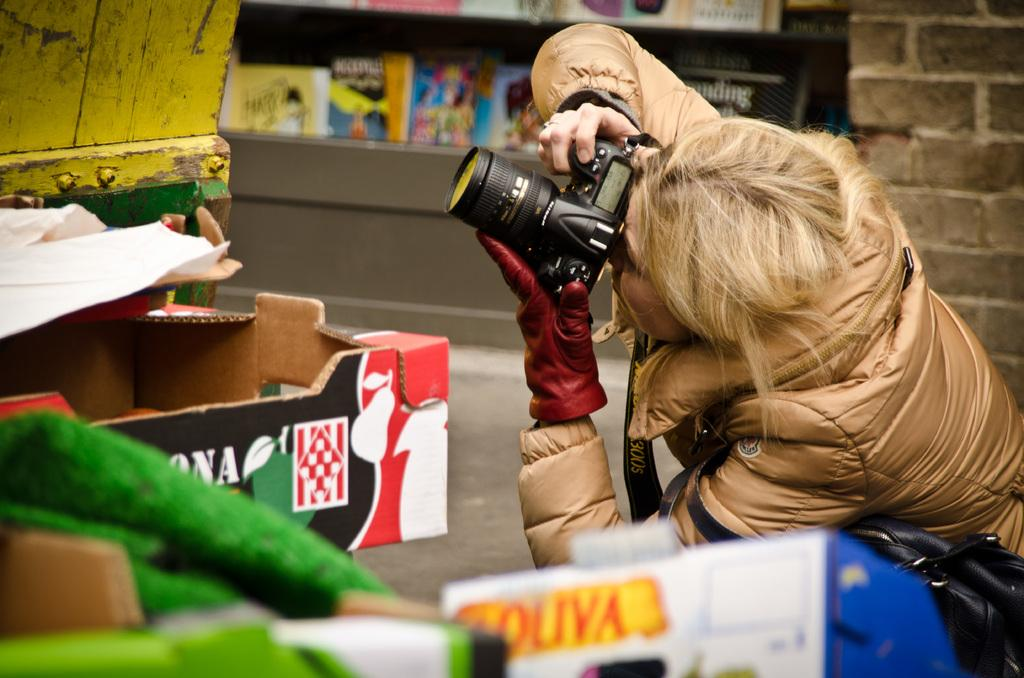What is the main subject of the image? The main subject of the image is a woman. What is the woman holding in the image? The woman is holding a camera. What is the woman doing with the camera? The woman is capturing a picture. What type of comfort can be seen in the image? There is no specific type of comfort visible in the image. What scene is the woman capturing in the image? The provided facts do not specify the scene the woman is capturing. 